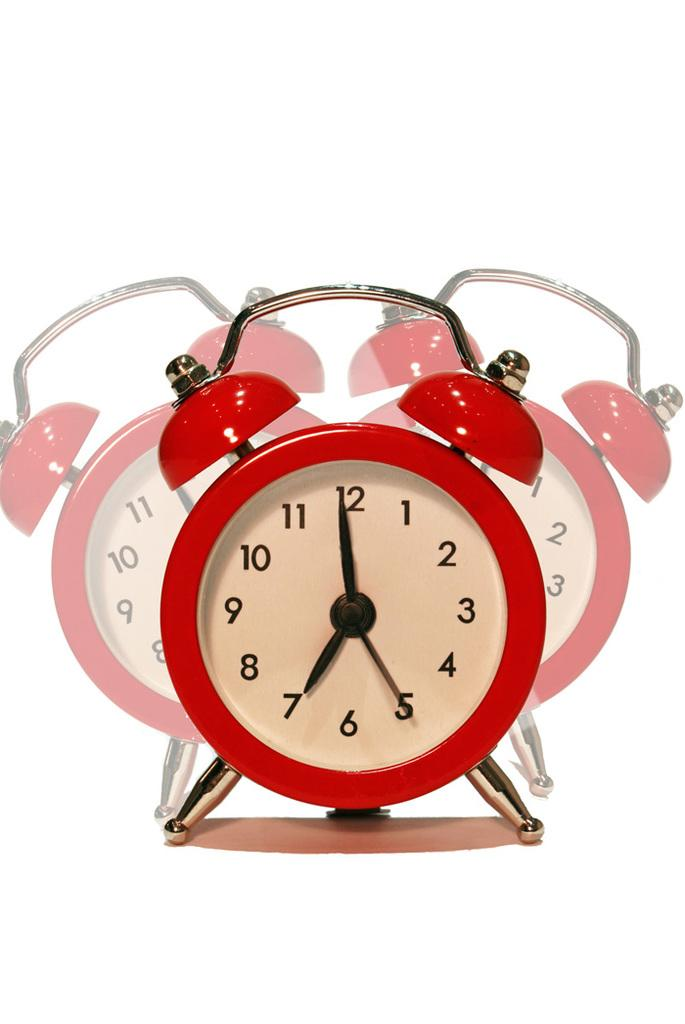<image>
Present a compact description of the photo's key features. Red alarm clock with the hands on 7 and 12. 